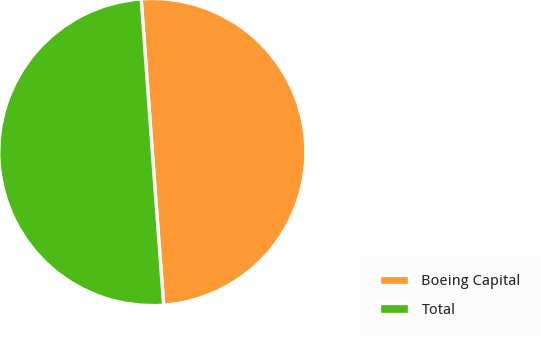Convert chart. <chart><loc_0><loc_0><loc_500><loc_500><pie_chart><fcel>Boeing Capital<fcel>Total<nl><fcel>49.98%<fcel>50.02%<nl></chart> 